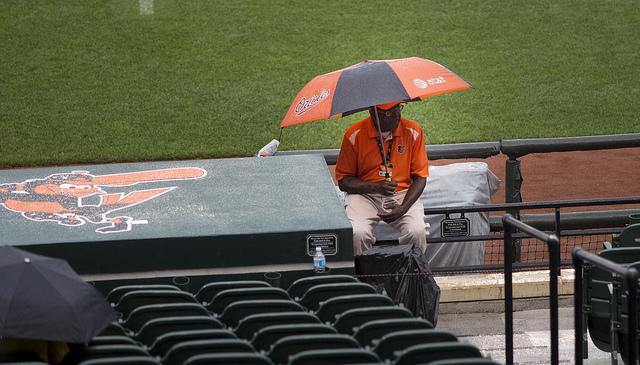Is the man wearing a uniform?
Quick response, please. Yes. Is this man barbecuing?
Answer briefly. No. What color is the umbrella?
Be succinct. Orange and black. Is it raining?
Give a very brief answer. No. What color is the umpire's seat?
Answer briefly. Black. 